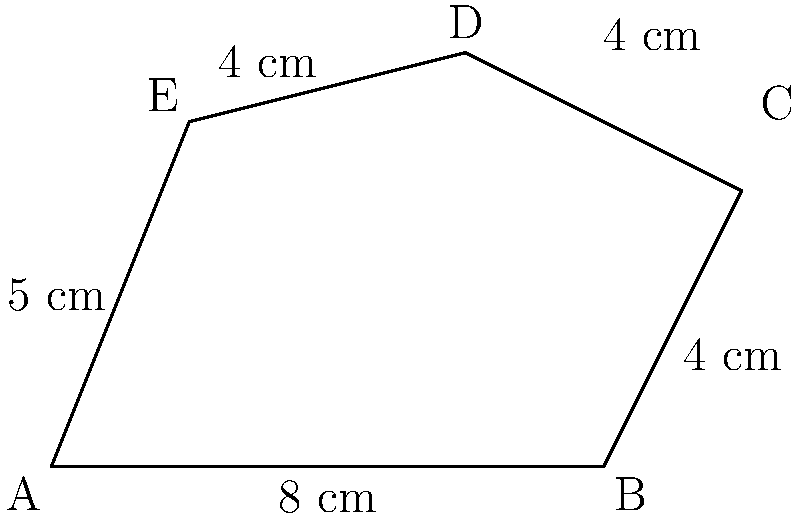A Symbolist painter is working on an irregularly shaped canvas for their latest masterpiece. The canvas has the shape shown in the diagram above. Calculate the area of this canvas in square centimeters. To find the area of this irregular shape, we can divide it into simpler geometric shapes:

1. Rectangle ABFE:
   Width = 8 cm, Height = 5 cm
   Area of rectangle = $8 \times 5 = 40$ cm²

2. Right triangle BCF:
   Base = 2 cm, Height = 4 cm
   Area of triangle = $\frac{1}{2} \times 2 \times 4 = 4$ cm²

3. Trapezoid CDEF:
   Parallel sides: CD = 4 cm, EF = 4 cm
   Height = 1 cm (difference between D's y-coordinate and C's y-coordinate)
   Area of trapezoid = $\frac{1}{2}(4 + 4) \times 1 = 4$ cm²

Total area:
$$\text{Area}_{\text{total}} = \text{Area}_{\text{rectangle}} + \text{Area}_{\text{triangle}} + \text{Area}_{\text{trapezoid}}$$
$$\text{Area}_{\text{total}} = 40 + 4 + 4 = 48 \text{ cm²}$$

Therefore, the area of the irregular canvas is 48 square centimeters.
Answer: 48 cm² 